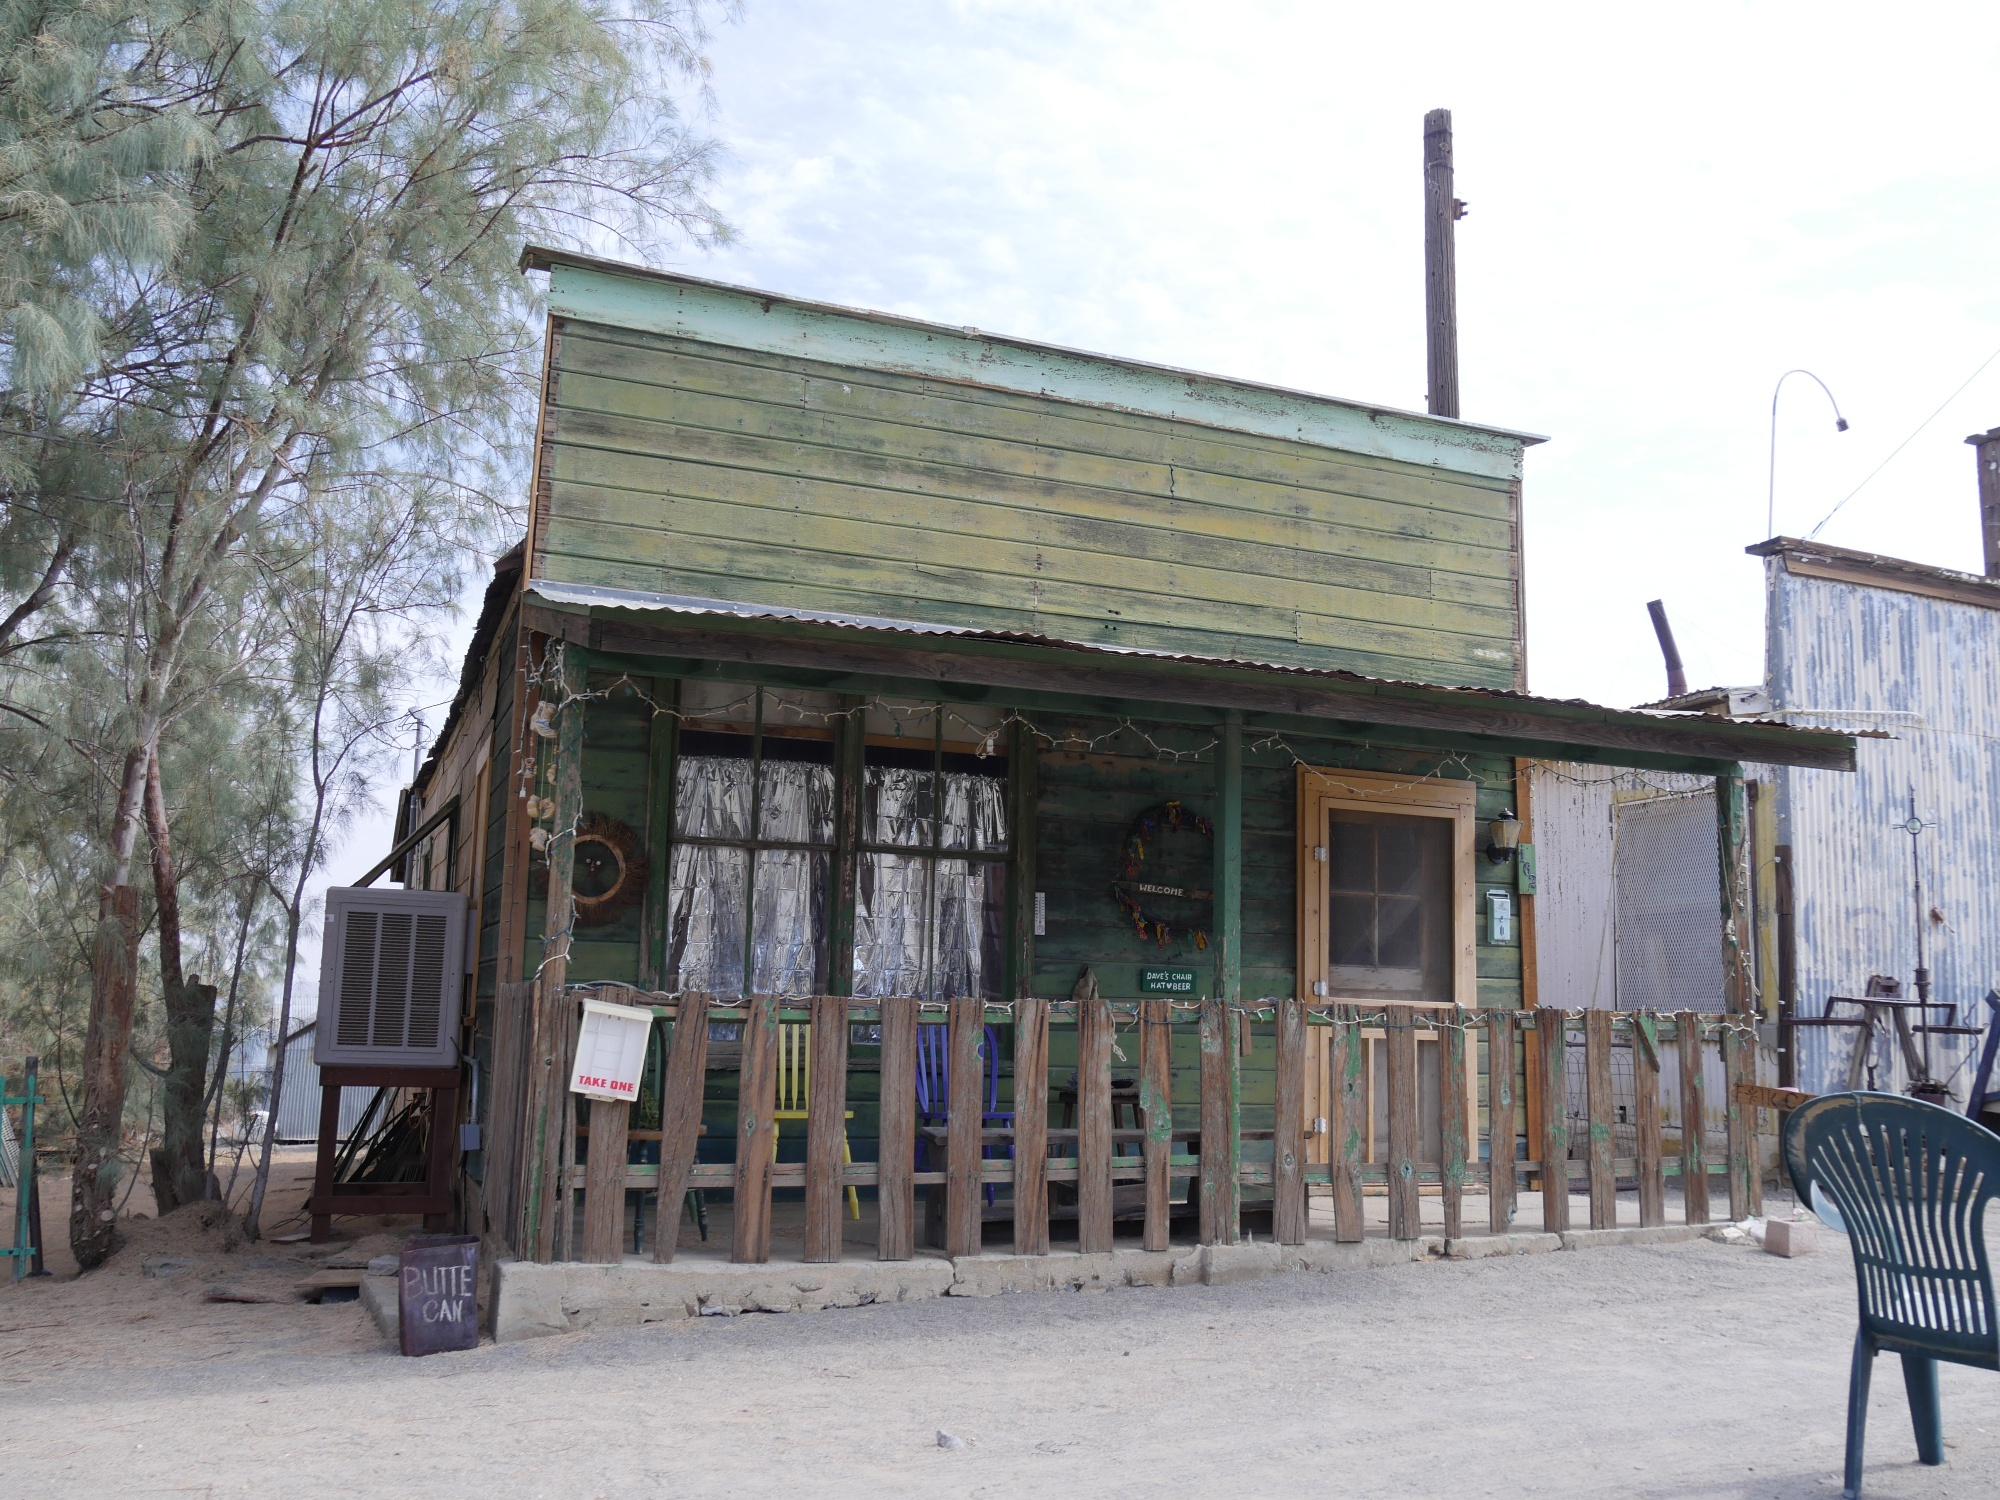What's happening in the scene? The image depicts a rustic, weathered wooden building with a green roof and a chimney, suggesting it may have been a home or a small business in the past. The building’s paint is faded, reflecting abandonment and the passage of time. In front of it, a wooden fence stands partly surrounded by various items—a chair, a trash can, and an old tire—contributing to the sense of neglect. A notable feature is a sign reading 'Route 66,' which adds a historical and nostalgic dimension, evoking thoughts of travels along the famous highway. The area around the building is surrounded by trees, their green leaves creating a contrast against the worn structure, further enhancing the feeling of a forgotten, yet once lively place. 